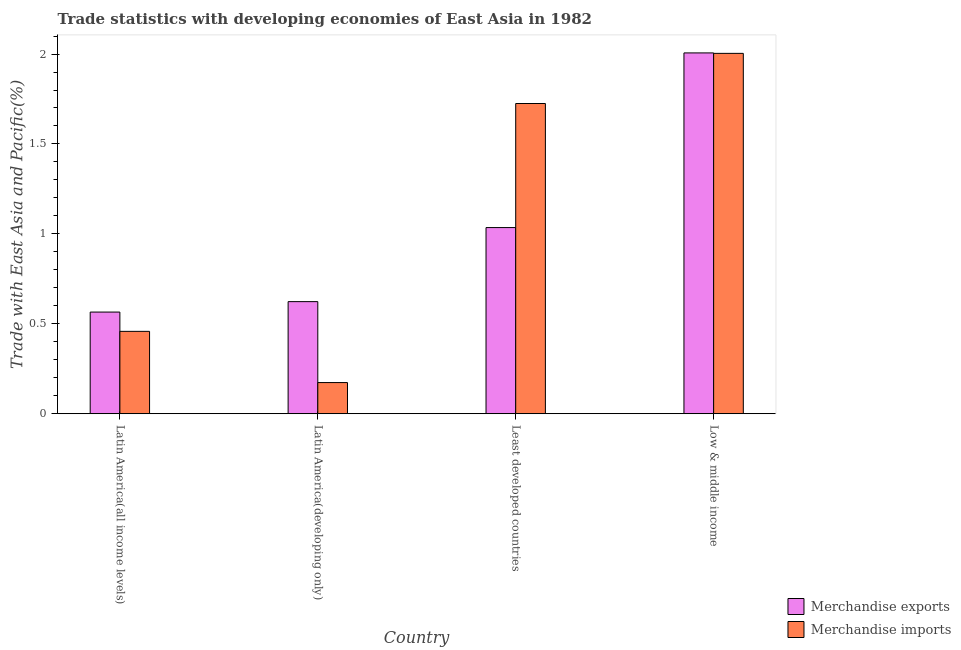How many groups of bars are there?
Keep it short and to the point. 4. Are the number of bars per tick equal to the number of legend labels?
Make the answer very short. Yes. Are the number of bars on each tick of the X-axis equal?
Ensure brevity in your answer.  Yes. How many bars are there on the 1st tick from the left?
Provide a succinct answer. 2. What is the label of the 2nd group of bars from the left?
Your answer should be very brief. Latin America(developing only). In how many cases, is the number of bars for a given country not equal to the number of legend labels?
Provide a short and direct response. 0. What is the merchandise exports in Latin America(all income levels)?
Provide a succinct answer. 0.57. Across all countries, what is the maximum merchandise imports?
Offer a very short reply. 2. Across all countries, what is the minimum merchandise exports?
Make the answer very short. 0.57. In which country was the merchandise imports maximum?
Your response must be concise. Low & middle income. In which country was the merchandise imports minimum?
Offer a terse response. Latin America(developing only). What is the total merchandise exports in the graph?
Offer a terse response. 4.23. What is the difference between the merchandise imports in Latin America(developing only) and that in Least developed countries?
Your answer should be compact. -1.55. What is the difference between the merchandise imports in Latin America(developing only) and the merchandise exports in Least developed countries?
Your answer should be very brief. -0.86. What is the average merchandise imports per country?
Ensure brevity in your answer.  1.09. What is the difference between the merchandise imports and merchandise exports in Latin America(developing only)?
Your answer should be compact. -0.45. What is the ratio of the merchandise exports in Latin America(developing only) to that in Least developed countries?
Your response must be concise. 0.6. Is the merchandise exports in Latin America(all income levels) less than that in Least developed countries?
Offer a very short reply. Yes. Is the difference between the merchandise exports in Latin America(developing only) and Low & middle income greater than the difference between the merchandise imports in Latin America(developing only) and Low & middle income?
Your answer should be very brief. Yes. What is the difference between the highest and the second highest merchandise imports?
Give a very brief answer. 0.28. What is the difference between the highest and the lowest merchandise exports?
Offer a terse response. 1.44. In how many countries, is the merchandise exports greater than the average merchandise exports taken over all countries?
Offer a terse response. 1. Is the sum of the merchandise exports in Least developed countries and Low & middle income greater than the maximum merchandise imports across all countries?
Provide a succinct answer. Yes. What does the 2nd bar from the left in Least developed countries represents?
Give a very brief answer. Merchandise imports. Are all the bars in the graph horizontal?
Provide a short and direct response. No. What is the difference between two consecutive major ticks on the Y-axis?
Your answer should be very brief. 0.5. Does the graph contain any zero values?
Make the answer very short. No. Does the graph contain grids?
Give a very brief answer. No. Where does the legend appear in the graph?
Provide a succinct answer. Bottom right. What is the title of the graph?
Keep it short and to the point. Trade statistics with developing economies of East Asia in 1982. Does "Travel Items" appear as one of the legend labels in the graph?
Your answer should be compact. No. What is the label or title of the Y-axis?
Keep it short and to the point. Trade with East Asia and Pacific(%). What is the Trade with East Asia and Pacific(%) of Merchandise exports in Latin America(all income levels)?
Make the answer very short. 0.57. What is the Trade with East Asia and Pacific(%) of Merchandise imports in Latin America(all income levels)?
Give a very brief answer. 0.46. What is the Trade with East Asia and Pacific(%) of Merchandise exports in Latin America(developing only)?
Make the answer very short. 0.62. What is the Trade with East Asia and Pacific(%) in Merchandise imports in Latin America(developing only)?
Your answer should be compact. 0.17. What is the Trade with East Asia and Pacific(%) in Merchandise exports in Least developed countries?
Offer a terse response. 1.04. What is the Trade with East Asia and Pacific(%) in Merchandise imports in Least developed countries?
Make the answer very short. 1.72. What is the Trade with East Asia and Pacific(%) in Merchandise exports in Low & middle income?
Your response must be concise. 2.01. What is the Trade with East Asia and Pacific(%) of Merchandise imports in Low & middle income?
Ensure brevity in your answer.  2. Across all countries, what is the maximum Trade with East Asia and Pacific(%) in Merchandise exports?
Your answer should be compact. 2.01. Across all countries, what is the maximum Trade with East Asia and Pacific(%) of Merchandise imports?
Your answer should be very brief. 2. Across all countries, what is the minimum Trade with East Asia and Pacific(%) of Merchandise exports?
Make the answer very short. 0.57. Across all countries, what is the minimum Trade with East Asia and Pacific(%) of Merchandise imports?
Your answer should be very brief. 0.17. What is the total Trade with East Asia and Pacific(%) in Merchandise exports in the graph?
Your answer should be very brief. 4.23. What is the total Trade with East Asia and Pacific(%) of Merchandise imports in the graph?
Keep it short and to the point. 4.36. What is the difference between the Trade with East Asia and Pacific(%) of Merchandise exports in Latin America(all income levels) and that in Latin America(developing only)?
Your response must be concise. -0.06. What is the difference between the Trade with East Asia and Pacific(%) in Merchandise imports in Latin America(all income levels) and that in Latin America(developing only)?
Offer a very short reply. 0.28. What is the difference between the Trade with East Asia and Pacific(%) of Merchandise exports in Latin America(all income levels) and that in Least developed countries?
Your response must be concise. -0.47. What is the difference between the Trade with East Asia and Pacific(%) of Merchandise imports in Latin America(all income levels) and that in Least developed countries?
Your answer should be compact. -1.27. What is the difference between the Trade with East Asia and Pacific(%) in Merchandise exports in Latin America(all income levels) and that in Low & middle income?
Your answer should be compact. -1.44. What is the difference between the Trade with East Asia and Pacific(%) of Merchandise imports in Latin America(all income levels) and that in Low & middle income?
Your response must be concise. -1.55. What is the difference between the Trade with East Asia and Pacific(%) in Merchandise exports in Latin America(developing only) and that in Least developed countries?
Offer a very short reply. -0.41. What is the difference between the Trade with East Asia and Pacific(%) of Merchandise imports in Latin America(developing only) and that in Least developed countries?
Ensure brevity in your answer.  -1.55. What is the difference between the Trade with East Asia and Pacific(%) of Merchandise exports in Latin America(developing only) and that in Low & middle income?
Provide a succinct answer. -1.38. What is the difference between the Trade with East Asia and Pacific(%) in Merchandise imports in Latin America(developing only) and that in Low & middle income?
Make the answer very short. -1.83. What is the difference between the Trade with East Asia and Pacific(%) in Merchandise exports in Least developed countries and that in Low & middle income?
Your answer should be very brief. -0.97. What is the difference between the Trade with East Asia and Pacific(%) of Merchandise imports in Least developed countries and that in Low & middle income?
Offer a very short reply. -0.28. What is the difference between the Trade with East Asia and Pacific(%) in Merchandise exports in Latin America(all income levels) and the Trade with East Asia and Pacific(%) in Merchandise imports in Latin America(developing only)?
Your answer should be compact. 0.39. What is the difference between the Trade with East Asia and Pacific(%) of Merchandise exports in Latin America(all income levels) and the Trade with East Asia and Pacific(%) of Merchandise imports in Least developed countries?
Offer a very short reply. -1.16. What is the difference between the Trade with East Asia and Pacific(%) of Merchandise exports in Latin America(all income levels) and the Trade with East Asia and Pacific(%) of Merchandise imports in Low & middle income?
Your answer should be compact. -1.44. What is the difference between the Trade with East Asia and Pacific(%) in Merchandise exports in Latin America(developing only) and the Trade with East Asia and Pacific(%) in Merchandise imports in Least developed countries?
Provide a succinct answer. -1.1. What is the difference between the Trade with East Asia and Pacific(%) in Merchandise exports in Latin America(developing only) and the Trade with East Asia and Pacific(%) in Merchandise imports in Low & middle income?
Your answer should be very brief. -1.38. What is the difference between the Trade with East Asia and Pacific(%) in Merchandise exports in Least developed countries and the Trade with East Asia and Pacific(%) in Merchandise imports in Low & middle income?
Provide a short and direct response. -0.97. What is the average Trade with East Asia and Pacific(%) of Merchandise exports per country?
Your answer should be very brief. 1.06. What is the average Trade with East Asia and Pacific(%) in Merchandise imports per country?
Keep it short and to the point. 1.09. What is the difference between the Trade with East Asia and Pacific(%) of Merchandise exports and Trade with East Asia and Pacific(%) of Merchandise imports in Latin America(all income levels)?
Provide a short and direct response. 0.11. What is the difference between the Trade with East Asia and Pacific(%) in Merchandise exports and Trade with East Asia and Pacific(%) in Merchandise imports in Latin America(developing only)?
Give a very brief answer. 0.45. What is the difference between the Trade with East Asia and Pacific(%) in Merchandise exports and Trade with East Asia and Pacific(%) in Merchandise imports in Least developed countries?
Make the answer very short. -0.69. What is the difference between the Trade with East Asia and Pacific(%) of Merchandise exports and Trade with East Asia and Pacific(%) of Merchandise imports in Low & middle income?
Make the answer very short. 0. What is the ratio of the Trade with East Asia and Pacific(%) of Merchandise exports in Latin America(all income levels) to that in Latin America(developing only)?
Provide a short and direct response. 0.91. What is the ratio of the Trade with East Asia and Pacific(%) in Merchandise imports in Latin America(all income levels) to that in Latin America(developing only)?
Offer a terse response. 2.64. What is the ratio of the Trade with East Asia and Pacific(%) of Merchandise exports in Latin America(all income levels) to that in Least developed countries?
Make the answer very short. 0.55. What is the ratio of the Trade with East Asia and Pacific(%) of Merchandise imports in Latin America(all income levels) to that in Least developed countries?
Ensure brevity in your answer.  0.27. What is the ratio of the Trade with East Asia and Pacific(%) in Merchandise exports in Latin America(all income levels) to that in Low & middle income?
Ensure brevity in your answer.  0.28. What is the ratio of the Trade with East Asia and Pacific(%) in Merchandise imports in Latin America(all income levels) to that in Low & middle income?
Give a very brief answer. 0.23. What is the ratio of the Trade with East Asia and Pacific(%) in Merchandise exports in Latin America(developing only) to that in Least developed countries?
Provide a short and direct response. 0.6. What is the ratio of the Trade with East Asia and Pacific(%) of Merchandise imports in Latin America(developing only) to that in Least developed countries?
Provide a succinct answer. 0.1. What is the ratio of the Trade with East Asia and Pacific(%) in Merchandise exports in Latin America(developing only) to that in Low & middle income?
Give a very brief answer. 0.31. What is the ratio of the Trade with East Asia and Pacific(%) in Merchandise imports in Latin America(developing only) to that in Low & middle income?
Provide a short and direct response. 0.09. What is the ratio of the Trade with East Asia and Pacific(%) of Merchandise exports in Least developed countries to that in Low & middle income?
Offer a terse response. 0.52. What is the ratio of the Trade with East Asia and Pacific(%) in Merchandise imports in Least developed countries to that in Low & middle income?
Ensure brevity in your answer.  0.86. What is the difference between the highest and the second highest Trade with East Asia and Pacific(%) in Merchandise exports?
Give a very brief answer. 0.97. What is the difference between the highest and the second highest Trade with East Asia and Pacific(%) in Merchandise imports?
Offer a very short reply. 0.28. What is the difference between the highest and the lowest Trade with East Asia and Pacific(%) in Merchandise exports?
Give a very brief answer. 1.44. What is the difference between the highest and the lowest Trade with East Asia and Pacific(%) of Merchandise imports?
Your answer should be compact. 1.83. 